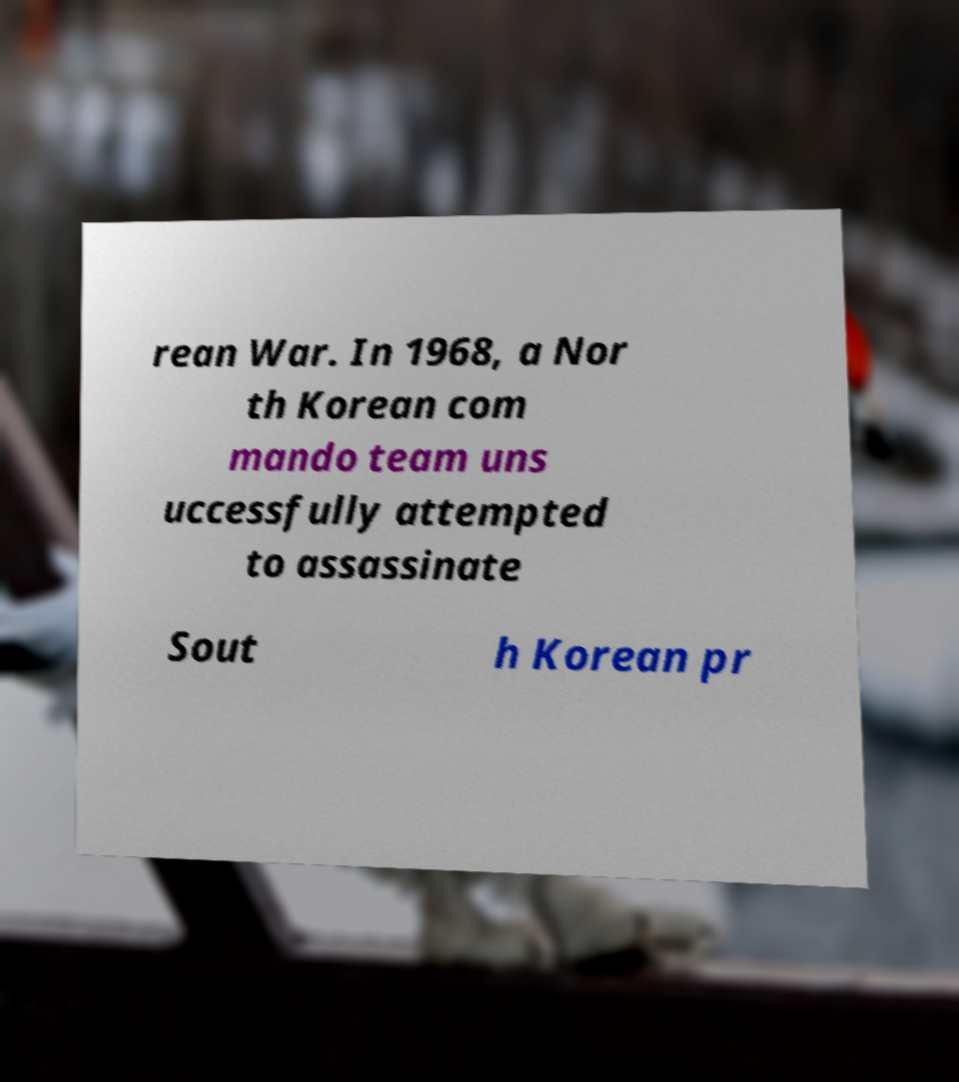Can you read and provide the text displayed in the image?This photo seems to have some interesting text. Can you extract and type it out for me? rean War. In 1968, a Nor th Korean com mando team uns uccessfully attempted to assassinate Sout h Korean pr 